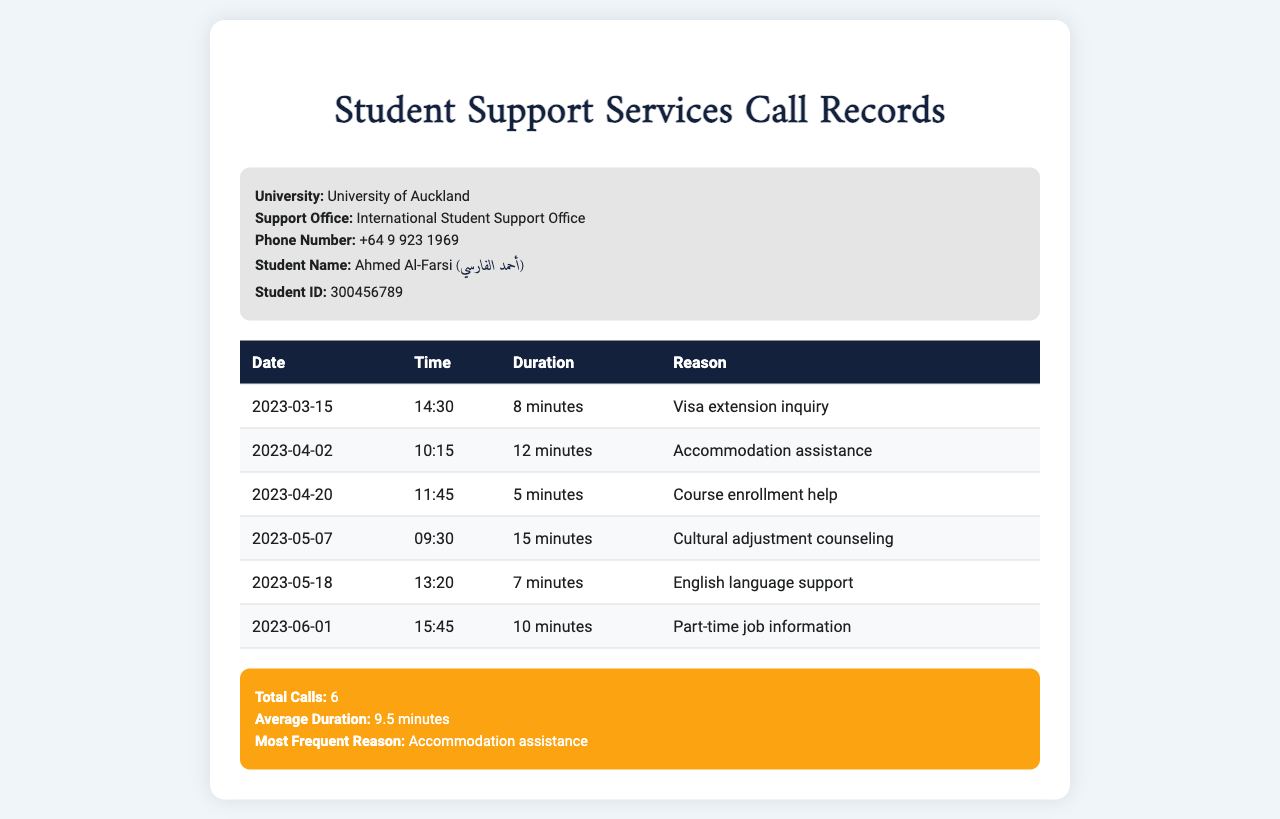what is the student name? The student name is listed in the document as "Ahmed Al-Farsi".
Answer: Ahmed Al-Farsi what is the total number of calls made? The total calls are summarized in the document, showing that there are 6 calls recorded.
Answer: 6 which support office was contacted? The support office's name is provided in the document as the "International Student Support Office".
Answer: International Student Support Office how long was the longest call? The longest call duration can be found in the table, noting that the maximum duration is 15 minutes.
Answer: 15 minutes what was the reason for the second call? The table lists the reasons for each call, and the second call is for "Accommodation assistance".
Answer: Accommodation assistance what is the average duration of calls? The average duration is calculated from all call durations provided in the summary section of the document, which is 9.5 minutes.
Answer: 9.5 minutes on what date did the call for cultural adjustment counseling take place? The specific date for the call regarding "Cultural adjustment counseling" is found in the table as "2023-05-07".
Answer: 2023-05-07 what time was the call about English language support made? The time of the call for "English language support" is listed in the table as 13:20.
Answer: 13:20 which call occurred on 2023-04-20? The document indicates that the call on this date was for "Course enrollment help".
Answer: Course enrollment help 